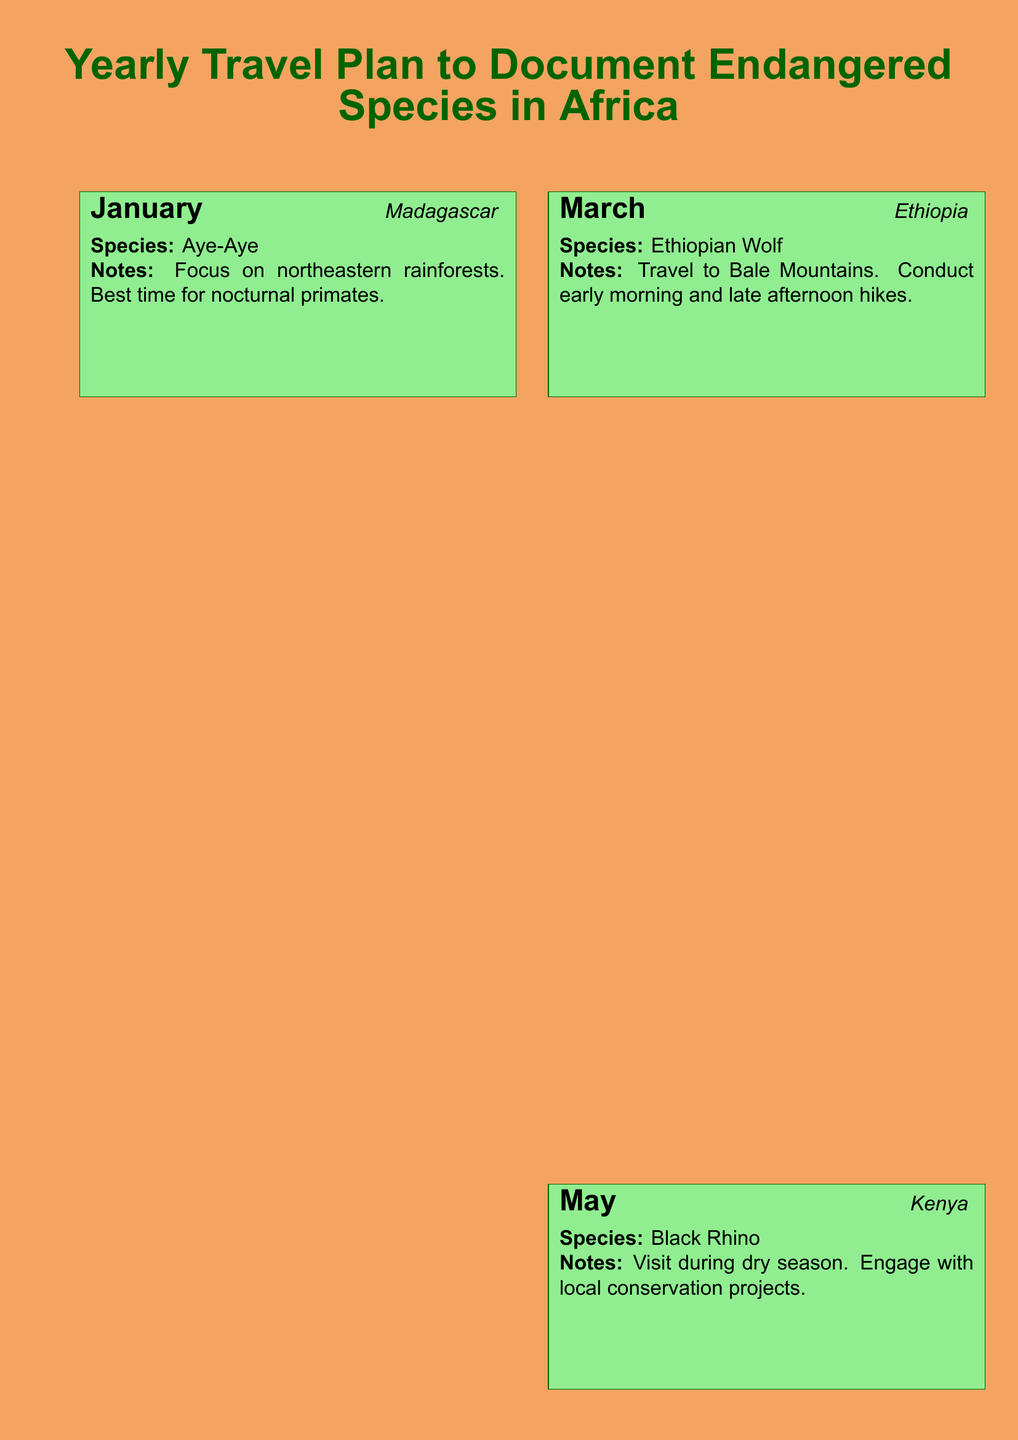What is the first destination listed for travel? The first destination listed for travel in January is Madagascar.
Answer: Madagascar Which endangered species is documented in Ethiopia? The document specifies the Ethiopian Wolf as the species to be documented in Ethiopia.
Answer: Ethiopian Wolf What month is focused on the African Penguin? The species of African Penguin is addressed in November.
Answer: November What conservation activity is suggested during the trip to Kenya? The document suggests engaging with local conservation projects while in Kenya.
Answer: Local conservation projects Which month is best for photographing the Eastern Black-and-white Colobus Monkey? The document indicates that September is the month with the best lighting conditions for this species.
Answer: September What type of photography practices should be maintained? The note states that ethical wildlife photography practices should be maintained to avoid disturbance.
Answer: Ethical wildlife photography How many destinations are listed in the travel plan? By counting the months with assigned destinations, there are six total destinations listed.
Answer: Six What should be packed for the travels? The document advises to pack appropriately for various climates and terrains.
Answer: Appropriately for various climates and terrains In which country can Forest Elephants be found according to the plan? The document states that Forest Elephants can be found in Gabon.
Answer: Gabon 